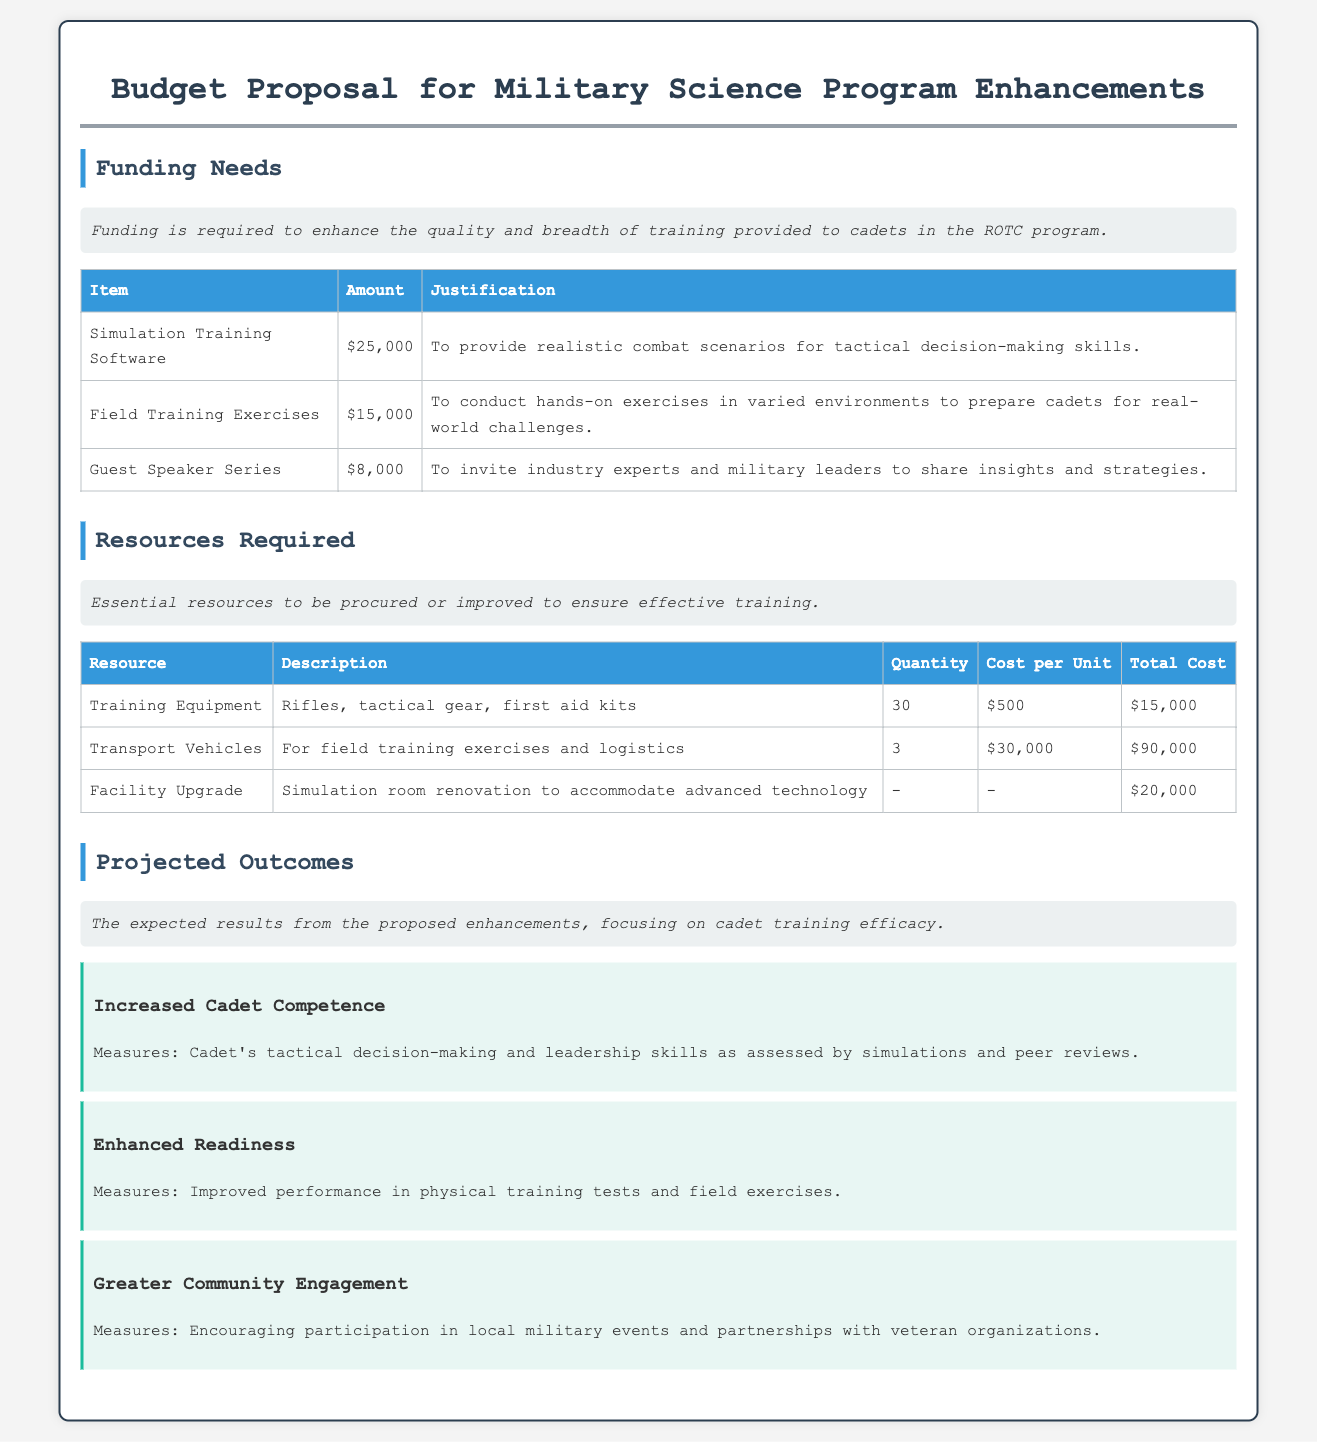What is the total amount needed for Simulation Training Software? The amount needed for Simulation Training Software is specified in the funding needs section of the document as $25,000.
Answer: $25,000 What is the total cost for Transport Vehicles? The total cost for Transport Vehicles is calculated by multiplying the cost per unit by the quantity, which is $30,000 multiplied by 3, resulting in $90,000.
Answer: $90,000 How many rifles and tactical gear are required? The quantity of training equipment is listed as 30 units, which includes rifles and tactical gear.
Answer: 30 What is the cost for Facility Upgrade? The total cost for Facility Upgrade is made clear in the resources required section, which states it as $20,000.
Answer: $20,000 What type of training does the Simulation Training Software provide? The document states that Simulation Training Software is for providing realistic combat scenarios for tactical decision-making skills.
Answer: Realistic combat scenarios What is the focus of the Projected Outcomes? The projected outcomes are centered around the expected results of enhancements regarding cadet training efficacy.
Answer: Cadet training efficacy What are the expected measures for Increased Cadet Competence? The expected measures for Increased Cadet Competence focus on cadet's tactical decision-making and leadership skills as assessed by simulations and peer reviews.
Answer: Tactical decision-making and leadership skills How many items are in the funding needs table? The funding needs table includes a total of 3 items listed for funding requirements.
Answer: 3 What does the Guest Speaker Series aim to do? The Guest Speaker Series aims to invite industry experts and military leaders to share insights and strategies with cadets.
Answer: Share insights and strategies What is one measure of Enhanced Readiness? One measure of Enhanced Readiness is the improved performance in physical training tests and field exercises.
Answer: Improved performance in physical training tests 